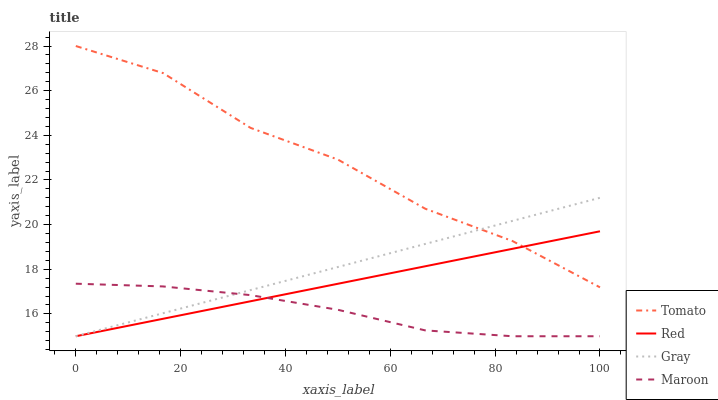Does Maroon have the minimum area under the curve?
Answer yes or no. Yes. Does Tomato have the maximum area under the curve?
Answer yes or no. Yes. Does Gray have the minimum area under the curve?
Answer yes or no. No. Does Gray have the maximum area under the curve?
Answer yes or no. No. Is Gray the smoothest?
Answer yes or no. Yes. Is Tomato the roughest?
Answer yes or no. Yes. Is Maroon the smoothest?
Answer yes or no. No. Is Maroon the roughest?
Answer yes or no. No. Does Gray have the lowest value?
Answer yes or no. Yes. Does Tomato have the highest value?
Answer yes or no. Yes. Does Gray have the highest value?
Answer yes or no. No. Is Maroon less than Tomato?
Answer yes or no. Yes. Is Tomato greater than Maroon?
Answer yes or no. Yes. Does Tomato intersect Gray?
Answer yes or no. Yes. Is Tomato less than Gray?
Answer yes or no. No. Is Tomato greater than Gray?
Answer yes or no. No. Does Maroon intersect Tomato?
Answer yes or no. No. 